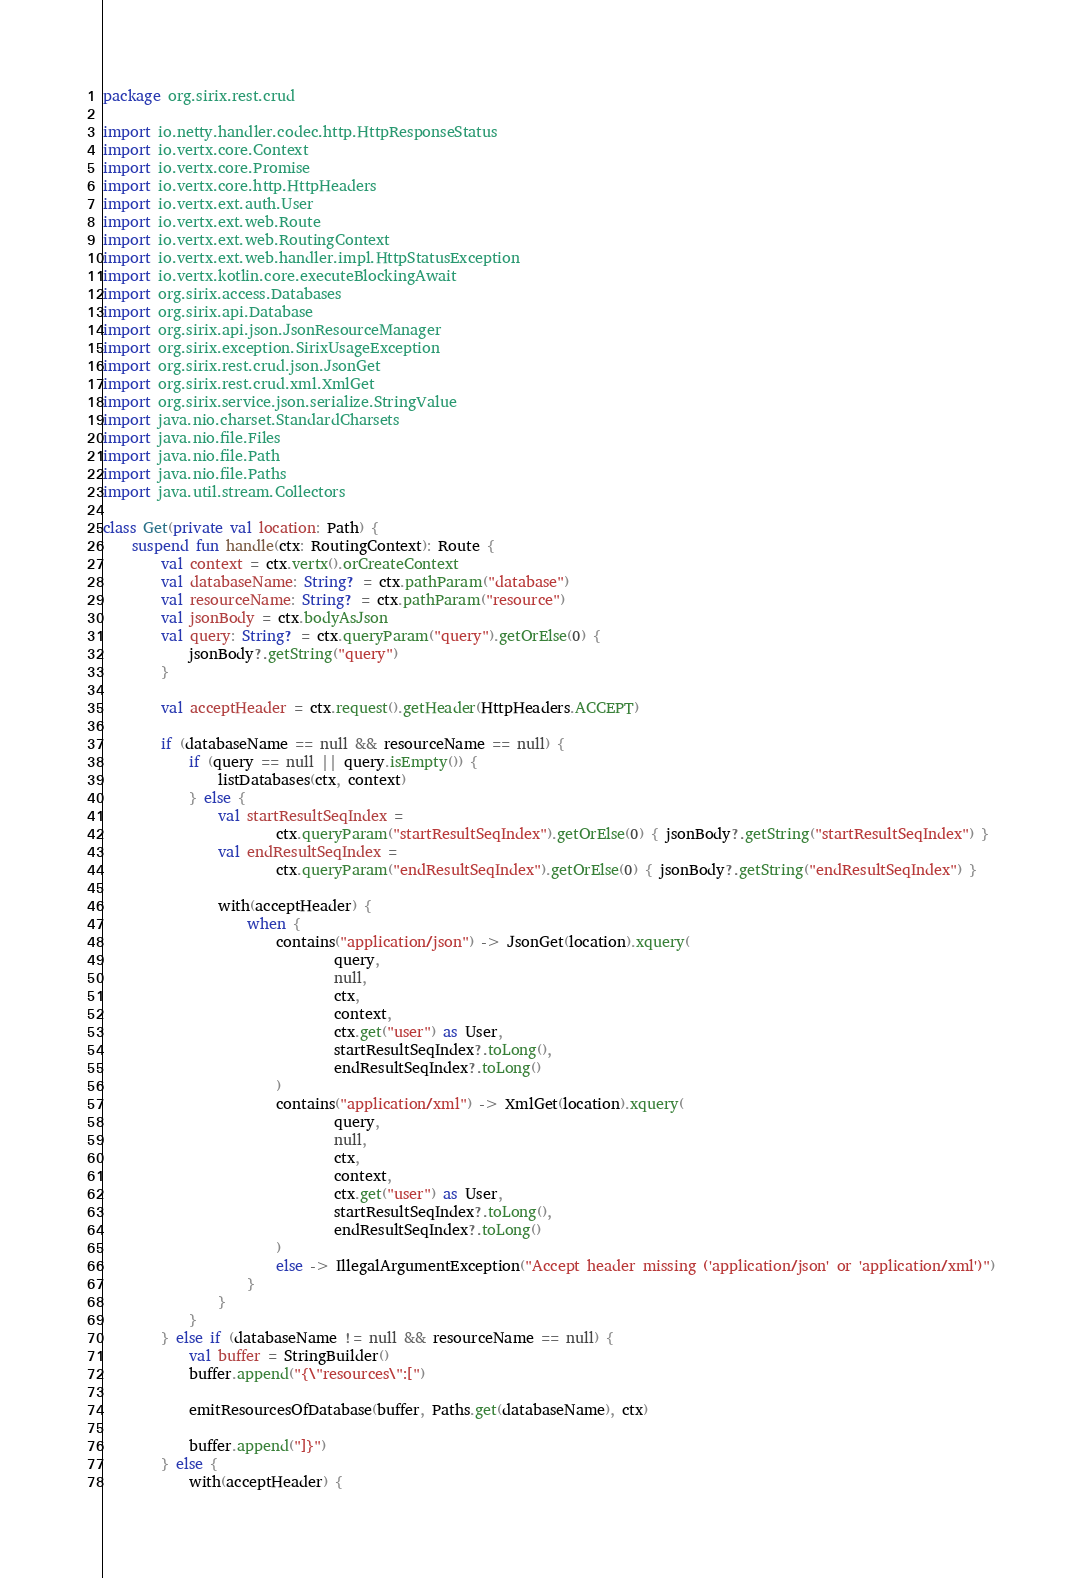<code> <loc_0><loc_0><loc_500><loc_500><_Kotlin_>package org.sirix.rest.crud

import io.netty.handler.codec.http.HttpResponseStatus
import io.vertx.core.Context
import io.vertx.core.Promise
import io.vertx.core.http.HttpHeaders
import io.vertx.ext.auth.User
import io.vertx.ext.web.Route
import io.vertx.ext.web.RoutingContext
import io.vertx.ext.web.handler.impl.HttpStatusException
import io.vertx.kotlin.core.executeBlockingAwait
import org.sirix.access.Databases
import org.sirix.api.Database
import org.sirix.api.json.JsonResourceManager
import org.sirix.exception.SirixUsageException
import org.sirix.rest.crud.json.JsonGet
import org.sirix.rest.crud.xml.XmlGet
import org.sirix.service.json.serialize.StringValue
import java.nio.charset.StandardCharsets
import java.nio.file.Files
import java.nio.file.Path
import java.nio.file.Paths
import java.util.stream.Collectors

class Get(private val location: Path) {
    suspend fun handle(ctx: RoutingContext): Route {
        val context = ctx.vertx().orCreateContext
        val databaseName: String? = ctx.pathParam("database")
        val resourceName: String? = ctx.pathParam("resource")
        val jsonBody = ctx.bodyAsJson
        val query: String? = ctx.queryParam("query").getOrElse(0) {
            jsonBody?.getString("query")
        }

        val acceptHeader = ctx.request().getHeader(HttpHeaders.ACCEPT)

        if (databaseName == null && resourceName == null) {
            if (query == null || query.isEmpty()) {
                listDatabases(ctx, context)
            } else {
                val startResultSeqIndex =
                        ctx.queryParam("startResultSeqIndex").getOrElse(0) { jsonBody?.getString("startResultSeqIndex") }
                val endResultSeqIndex =
                        ctx.queryParam("endResultSeqIndex").getOrElse(0) { jsonBody?.getString("endResultSeqIndex") }

                with(acceptHeader) {
                    when {
                        contains("application/json") -> JsonGet(location).xquery(
                                query,
                                null,
                                ctx,
                                context,
                                ctx.get("user") as User,
                                startResultSeqIndex?.toLong(),
                                endResultSeqIndex?.toLong()
                        )
                        contains("application/xml") -> XmlGet(location).xquery(
                                query,
                                null,
                                ctx,
                                context,
                                ctx.get("user") as User,
                                startResultSeqIndex?.toLong(),
                                endResultSeqIndex?.toLong()
                        )
                        else -> IllegalArgumentException("Accept header missing ('application/json' or 'application/xml')")
                    }
                }
            }
        } else if (databaseName != null && resourceName == null) {
            val buffer = StringBuilder()
            buffer.append("{\"resources\":[")

            emitResourcesOfDatabase(buffer, Paths.get(databaseName), ctx)

            buffer.append("]}")
        } else {
            with(acceptHeader) {</code> 